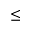Convert formula to latex. <formula><loc_0><loc_0><loc_500><loc_500>\leq</formula> 